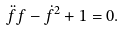<formula> <loc_0><loc_0><loc_500><loc_500>\ddot { f } f - \dot { f } ^ { 2 } + 1 = 0 .</formula> 